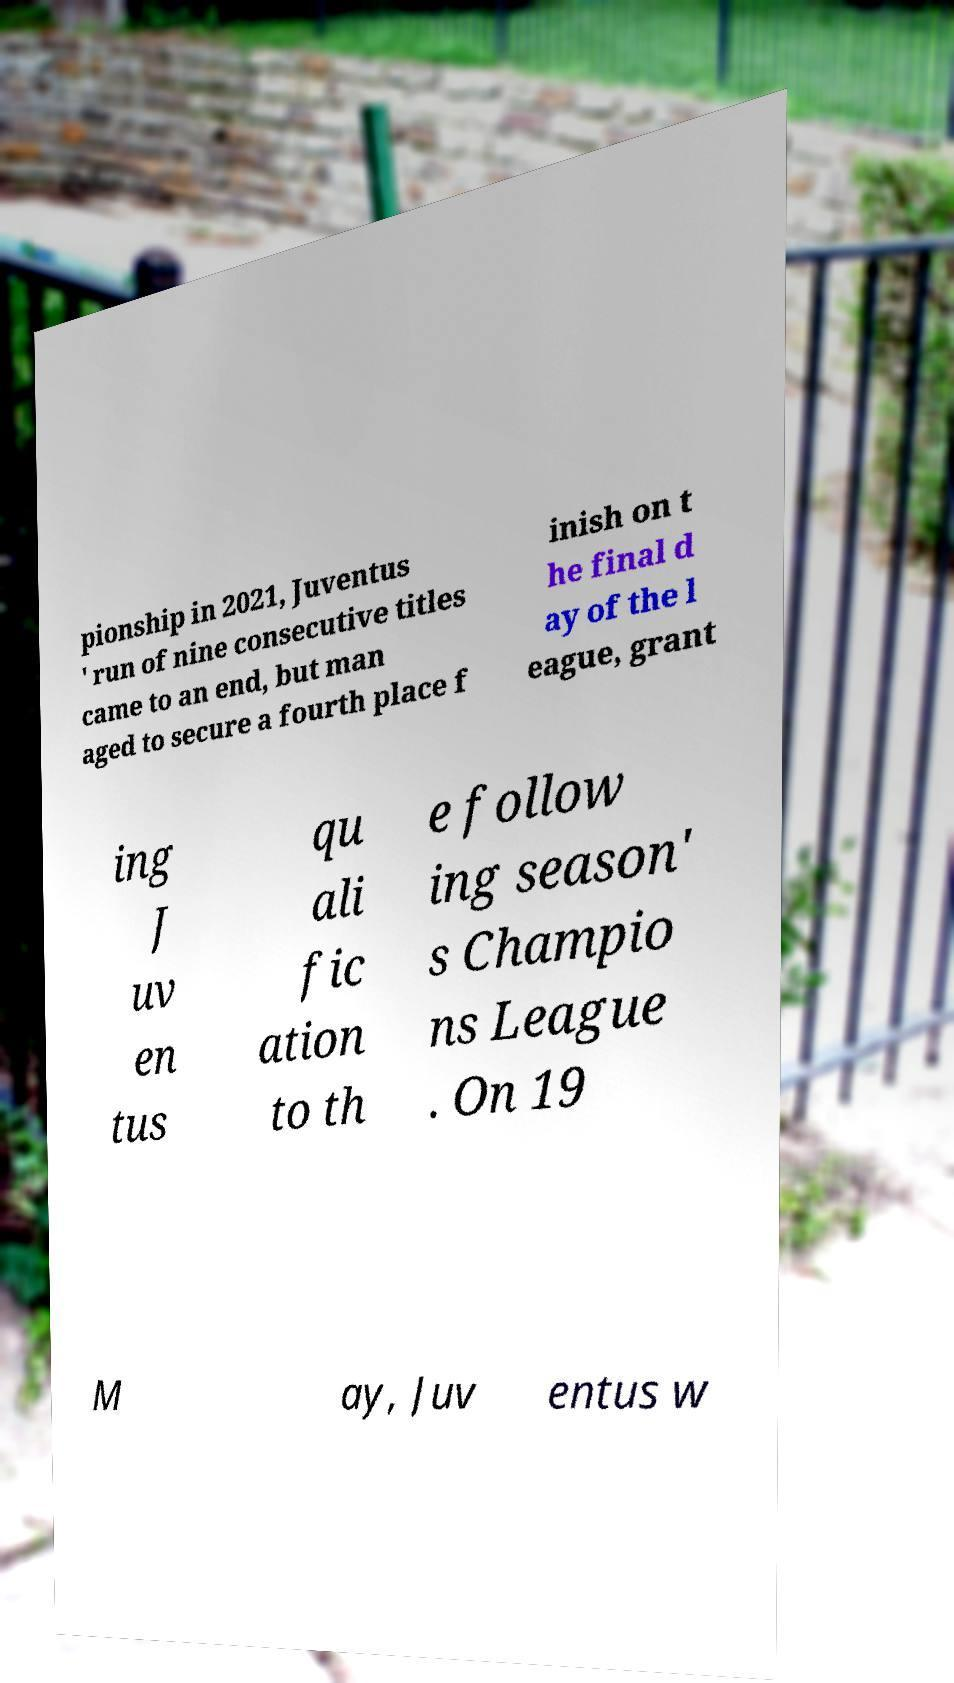I need the written content from this picture converted into text. Can you do that? pionship in 2021, Juventus ' run of nine consecutive titles came to an end, but man aged to secure a fourth place f inish on t he final d ay of the l eague, grant ing J uv en tus qu ali fic ation to th e follow ing season' s Champio ns League . On 19 M ay, Juv entus w 